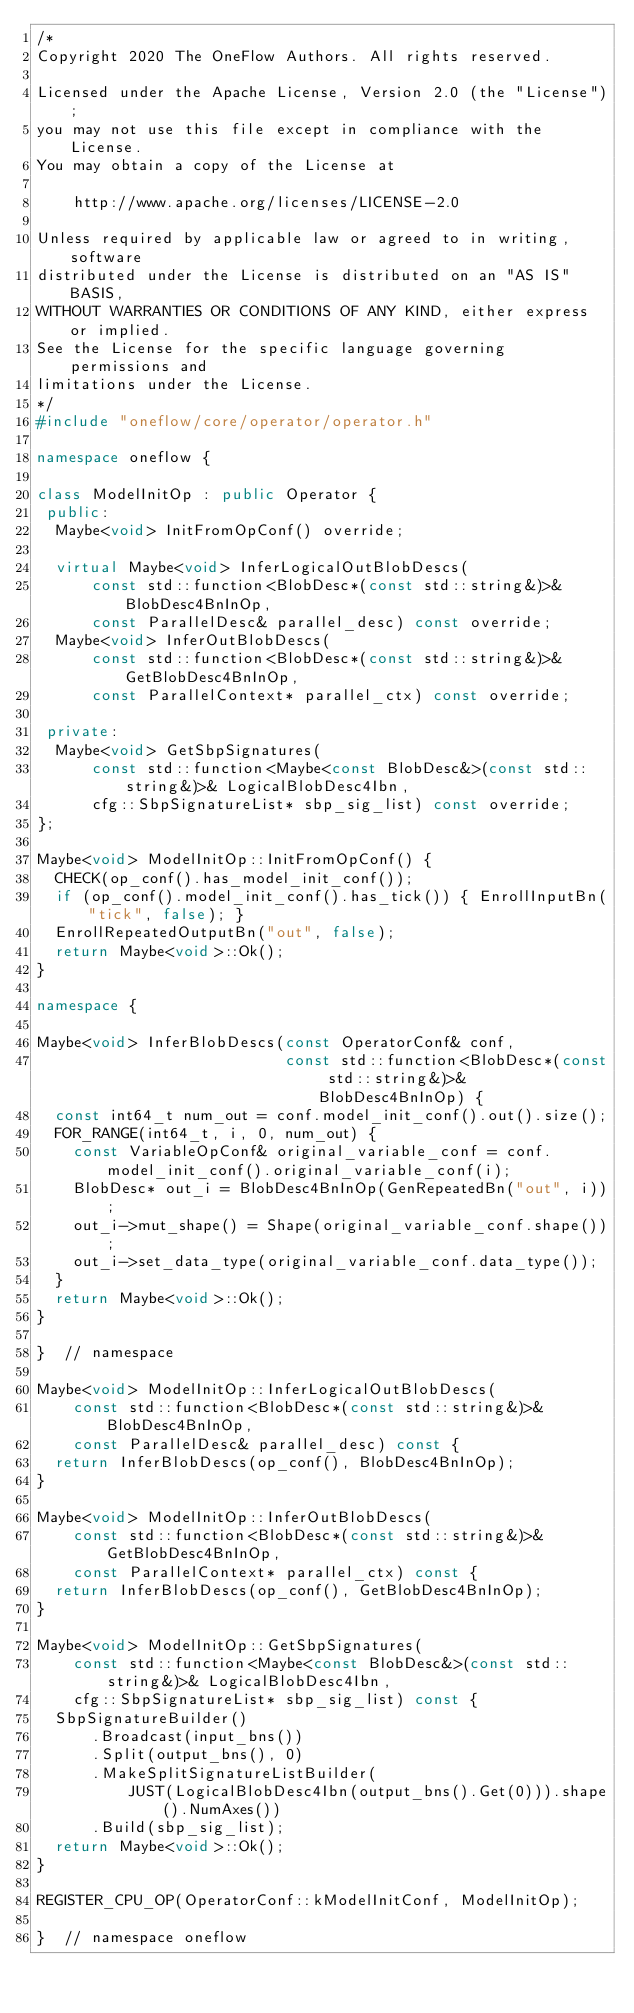Convert code to text. <code><loc_0><loc_0><loc_500><loc_500><_C++_>/*
Copyright 2020 The OneFlow Authors. All rights reserved.

Licensed under the Apache License, Version 2.0 (the "License");
you may not use this file except in compliance with the License.
You may obtain a copy of the License at

    http://www.apache.org/licenses/LICENSE-2.0

Unless required by applicable law or agreed to in writing, software
distributed under the License is distributed on an "AS IS" BASIS,
WITHOUT WARRANTIES OR CONDITIONS OF ANY KIND, either express or implied.
See the License for the specific language governing permissions and
limitations under the License.
*/
#include "oneflow/core/operator/operator.h"

namespace oneflow {

class ModelInitOp : public Operator {
 public:
  Maybe<void> InitFromOpConf() override;

  virtual Maybe<void> InferLogicalOutBlobDescs(
      const std::function<BlobDesc*(const std::string&)>& BlobDesc4BnInOp,
      const ParallelDesc& parallel_desc) const override;
  Maybe<void> InferOutBlobDescs(
      const std::function<BlobDesc*(const std::string&)>& GetBlobDesc4BnInOp,
      const ParallelContext* parallel_ctx) const override;

 private:
  Maybe<void> GetSbpSignatures(
      const std::function<Maybe<const BlobDesc&>(const std::string&)>& LogicalBlobDesc4Ibn,
      cfg::SbpSignatureList* sbp_sig_list) const override;
};

Maybe<void> ModelInitOp::InitFromOpConf() {
  CHECK(op_conf().has_model_init_conf());
  if (op_conf().model_init_conf().has_tick()) { EnrollInputBn("tick", false); }
  EnrollRepeatedOutputBn("out", false);
  return Maybe<void>::Ok();
}

namespace {

Maybe<void> InferBlobDescs(const OperatorConf& conf,
                           const std::function<BlobDesc*(const std::string&)>& BlobDesc4BnInOp) {
  const int64_t num_out = conf.model_init_conf().out().size();
  FOR_RANGE(int64_t, i, 0, num_out) {
    const VariableOpConf& original_variable_conf = conf.model_init_conf().original_variable_conf(i);
    BlobDesc* out_i = BlobDesc4BnInOp(GenRepeatedBn("out", i));
    out_i->mut_shape() = Shape(original_variable_conf.shape());
    out_i->set_data_type(original_variable_conf.data_type());
  }
  return Maybe<void>::Ok();
}

}  // namespace

Maybe<void> ModelInitOp::InferLogicalOutBlobDescs(
    const std::function<BlobDesc*(const std::string&)>& BlobDesc4BnInOp,
    const ParallelDesc& parallel_desc) const {
  return InferBlobDescs(op_conf(), BlobDesc4BnInOp);
}

Maybe<void> ModelInitOp::InferOutBlobDescs(
    const std::function<BlobDesc*(const std::string&)>& GetBlobDesc4BnInOp,
    const ParallelContext* parallel_ctx) const {
  return InferBlobDescs(op_conf(), GetBlobDesc4BnInOp);
}

Maybe<void> ModelInitOp::GetSbpSignatures(
    const std::function<Maybe<const BlobDesc&>(const std::string&)>& LogicalBlobDesc4Ibn,
    cfg::SbpSignatureList* sbp_sig_list) const {
  SbpSignatureBuilder()
      .Broadcast(input_bns())
      .Split(output_bns(), 0)
      .MakeSplitSignatureListBuilder(
          JUST(LogicalBlobDesc4Ibn(output_bns().Get(0))).shape().NumAxes())
      .Build(sbp_sig_list);
  return Maybe<void>::Ok();
}

REGISTER_CPU_OP(OperatorConf::kModelInitConf, ModelInitOp);

}  // namespace oneflow
</code> 